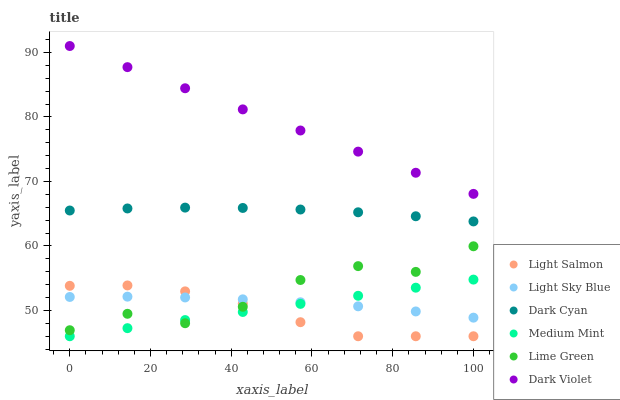Does Light Salmon have the minimum area under the curve?
Answer yes or no. Yes. Does Dark Violet have the maximum area under the curve?
Answer yes or no. Yes. Does Dark Violet have the minimum area under the curve?
Answer yes or no. No. Does Light Salmon have the maximum area under the curve?
Answer yes or no. No. Is Medium Mint the smoothest?
Answer yes or no. Yes. Is Lime Green the roughest?
Answer yes or no. Yes. Is Light Salmon the smoothest?
Answer yes or no. No. Is Light Salmon the roughest?
Answer yes or no. No. Does Medium Mint have the lowest value?
Answer yes or no. Yes. Does Dark Violet have the lowest value?
Answer yes or no. No. Does Dark Violet have the highest value?
Answer yes or no. Yes. Does Light Salmon have the highest value?
Answer yes or no. No. Is Lime Green less than Dark Violet?
Answer yes or no. Yes. Is Dark Cyan greater than Lime Green?
Answer yes or no. Yes. Does Light Salmon intersect Medium Mint?
Answer yes or no. Yes. Is Light Salmon less than Medium Mint?
Answer yes or no. No. Is Light Salmon greater than Medium Mint?
Answer yes or no. No. Does Lime Green intersect Dark Violet?
Answer yes or no. No. 